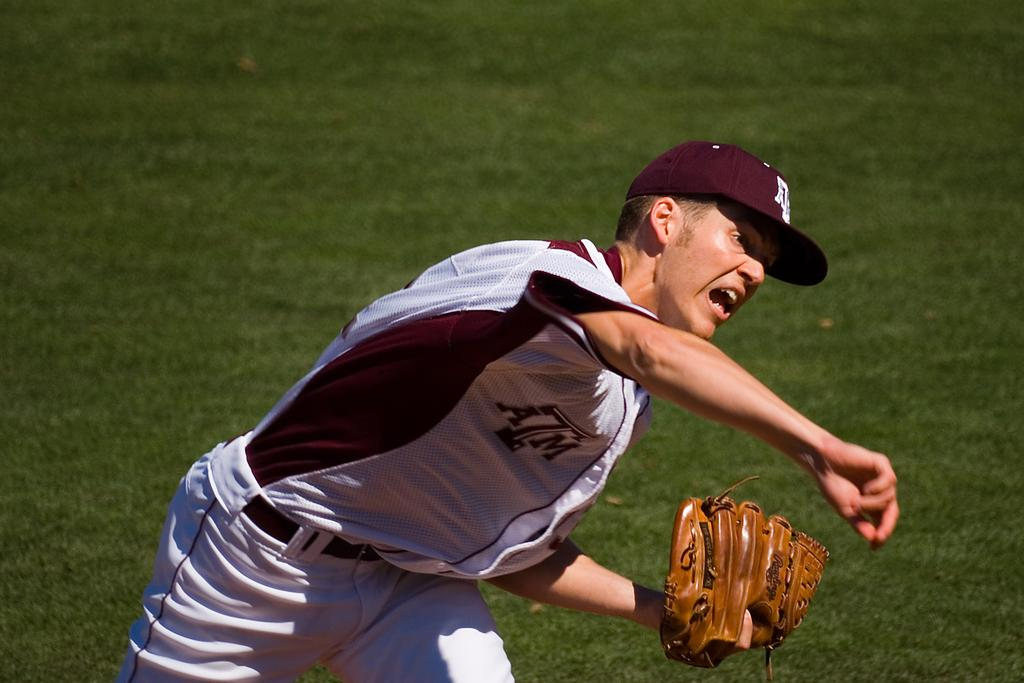<image>
Create a compact narrative representing the image presented. The pitcher for ATM just released the ball. 